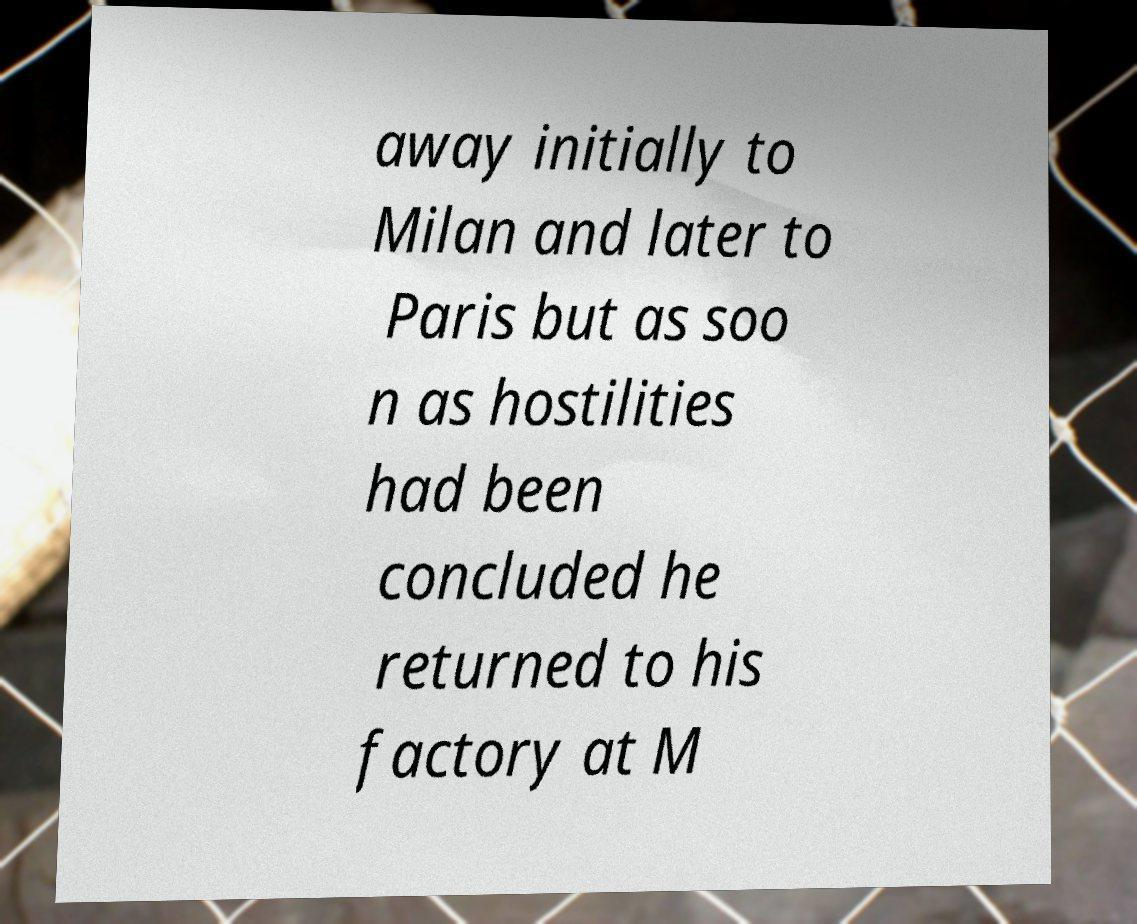There's text embedded in this image that I need extracted. Can you transcribe it verbatim? away initially to Milan and later to Paris but as soo n as hostilities had been concluded he returned to his factory at M 